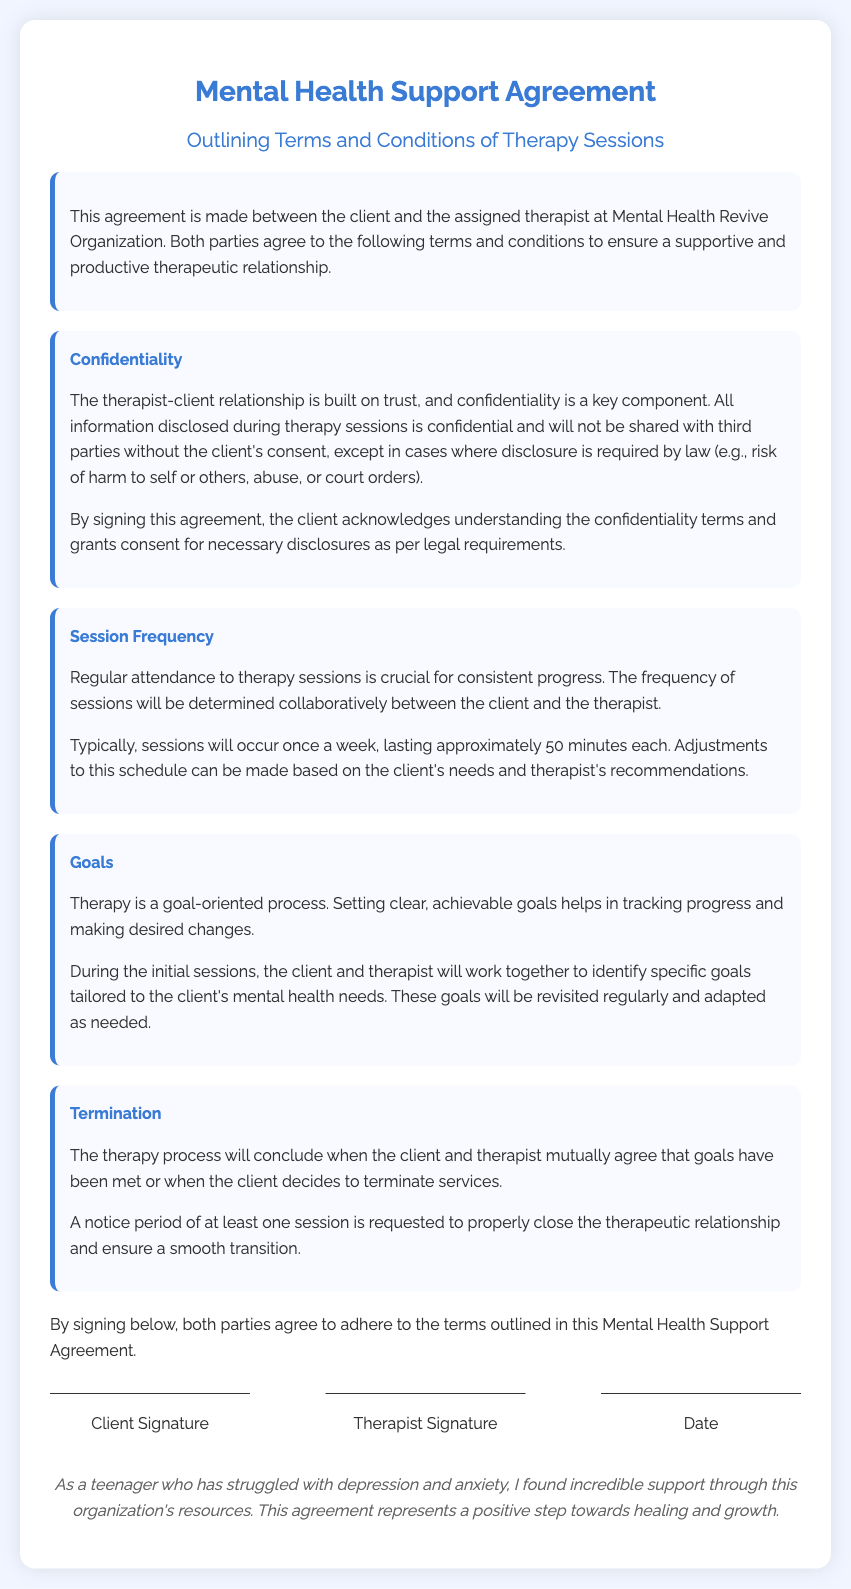what is the title of the agreement? The title of the agreement is clearly stated at the top of the document.
Answer: Mental Health Support Agreement how often will therapy sessions typically occur? The document specifies a typical frequency for therapy sessions.
Answer: once a week what is the duration of each therapy session? The document mentions the length of each session in minutes.
Answer: 50 minutes who is the agreement made between? The document identifies the parties involved in the agreement.
Answer: client and the assigned therapist what is required before terminating the therapy process? The document outlines a requirement for concluding therapy.
Answer: notice period of at least one session what is one condition under which confidentiality may be breached? The document lists specific circumstances where confidentiality does not apply.
Answer: risk of harm to self or others how will the client's goals be treated in therapy? The document describes how goals will be addressed during sessions.
Answer: identified and revisited regularly what is the main purpose of this therapy agreement? The central aim of the agreement is explained in a broad sense.
Answer: supportive and productive therapeutic relationship 